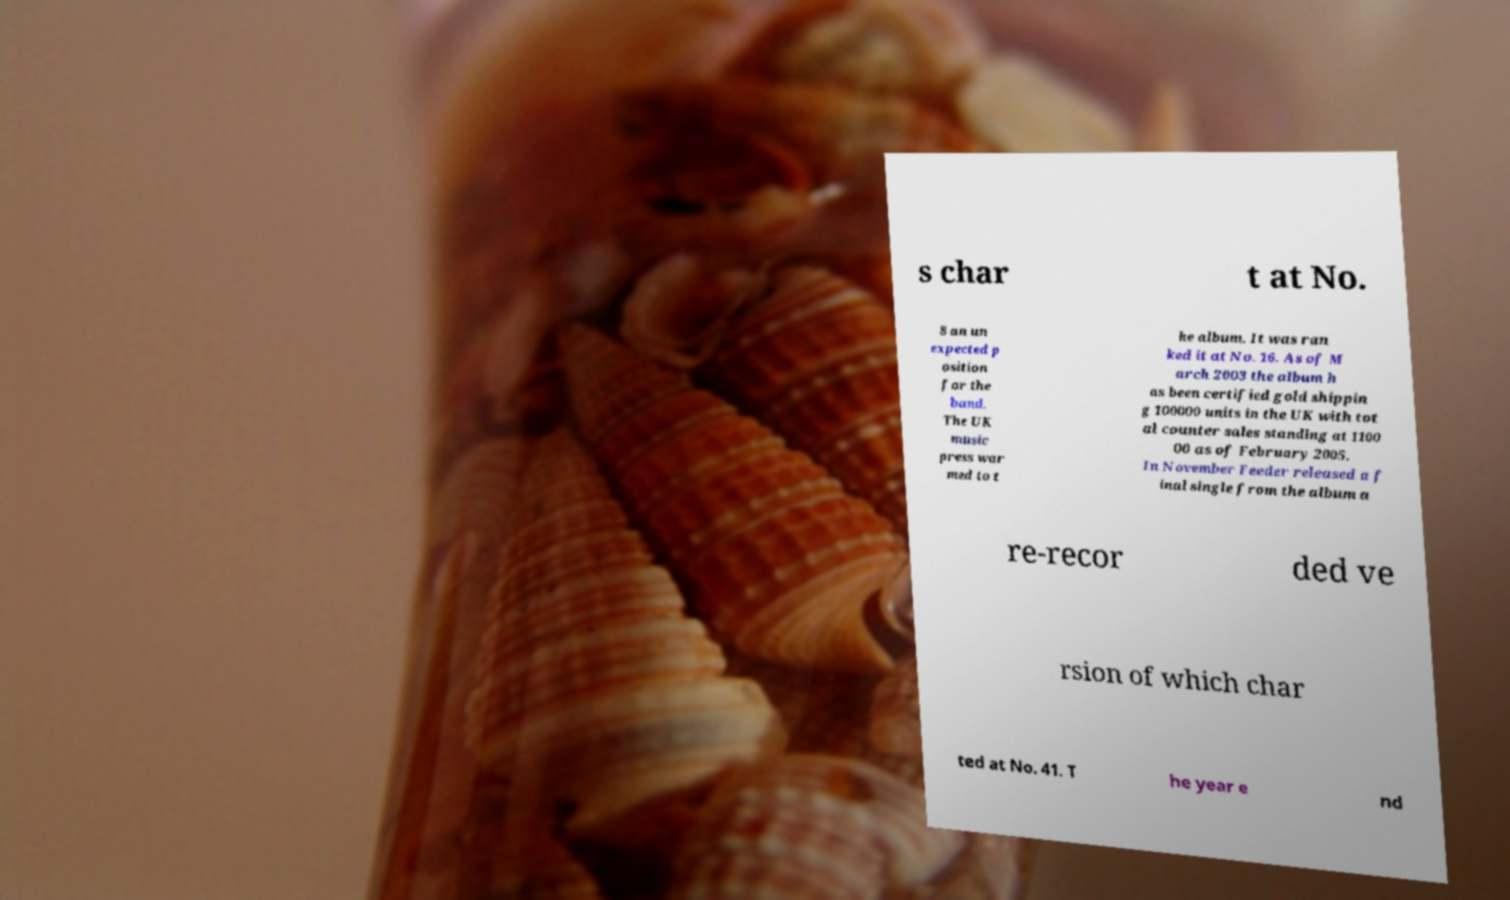For documentation purposes, I need the text within this image transcribed. Could you provide that? s char t at No. 8 an un expected p osition for the band. The UK music press war med to t he album. It was ran ked it at No. 16. As of M arch 2003 the album h as been certified gold shippin g 100000 units in the UK with tot al counter sales standing at 1100 00 as of February 2005. In November Feeder released a f inal single from the album a re-recor ded ve rsion of which char ted at No. 41. T he year e nd 